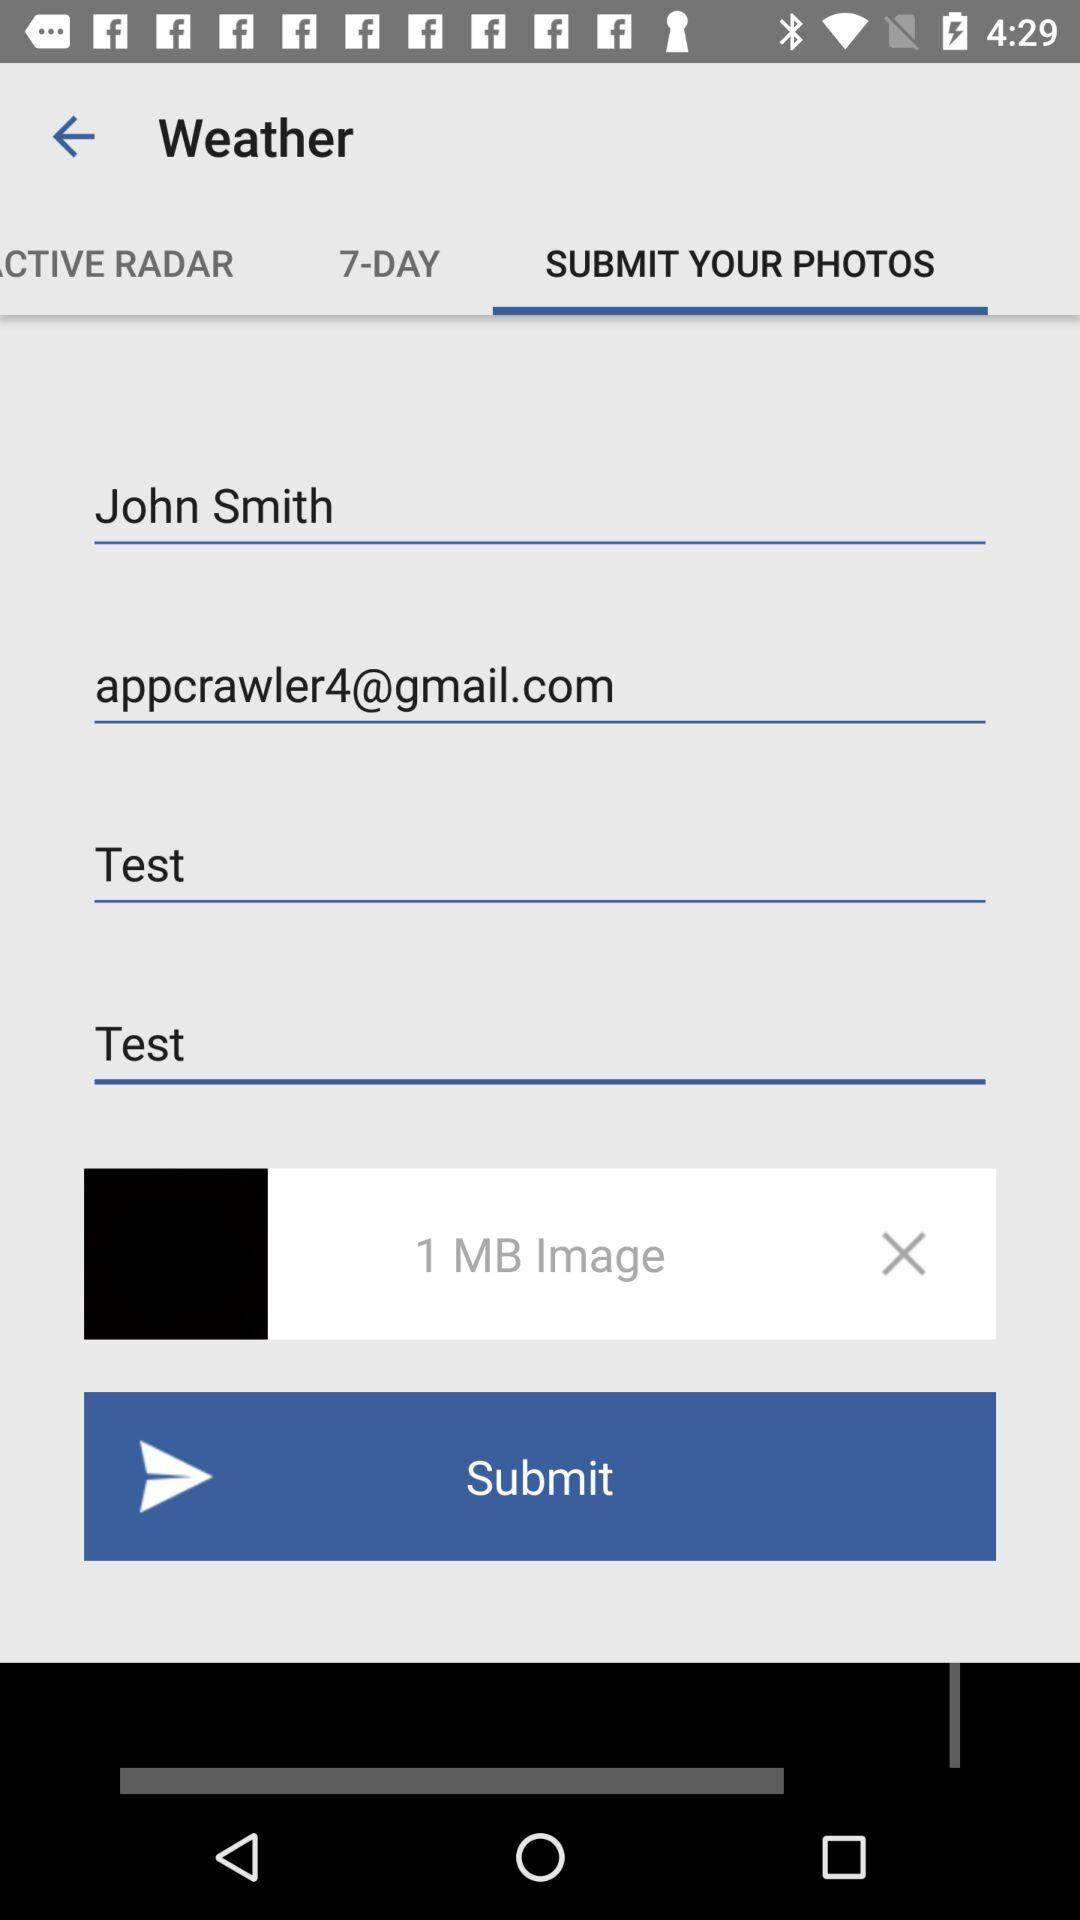What is the name? The name is John Smith. 